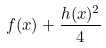Convert formula to latex. <formula><loc_0><loc_0><loc_500><loc_500>f ( x ) + \frac { h ( x ) ^ { 2 } } { 4 }</formula> 